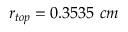Convert formula to latex. <formula><loc_0><loc_0><loc_500><loc_500>r _ { t o p } = 0 . 3 5 3 5 c m</formula> 